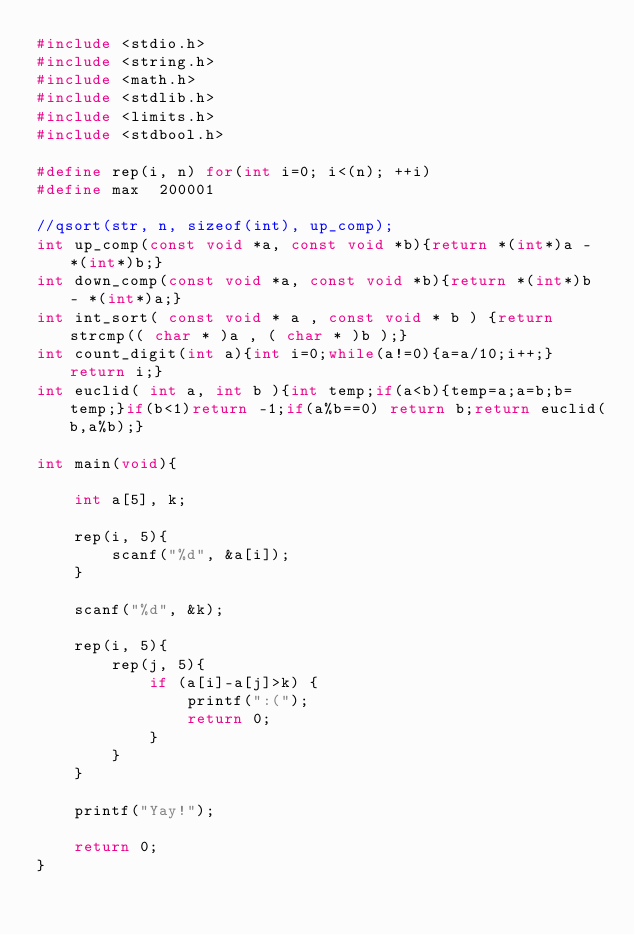<code> <loc_0><loc_0><loc_500><loc_500><_C_>#include <stdio.h>
#include <string.h>
#include <math.h>
#include <stdlib.h>
#include <limits.h>
#include <stdbool.h>

#define rep(i, n) for(int i=0; i<(n); ++i)
#define max  200001

//qsort(str, n, sizeof(int), up_comp);
int up_comp(const void *a, const void *b){return *(int*)a - *(int*)b;}
int down_comp(const void *a, const void *b){return *(int*)b - *(int*)a;}
int int_sort( const void * a , const void * b ) {return strcmp(( char * )a , ( char * )b );}
int count_digit(int a){int i=0;while(a!=0){a=a/10;i++;}return i;}
int euclid( int a, int b ){int temp;if(a<b){temp=a;a=b;b=temp;}if(b<1)return -1;if(a%b==0) return b;return euclid(b,a%b);}

int main(void){
 
    int a[5], k;
    
    rep(i, 5){
        scanf("%d", &a[i]);
    }
    
    scanf("%d", &k);

    rep(i, 5){
        rep(j, 5){
            if (a[i]-a[j]>k) {
                printf(":(");
                return 0;
            }
        }
    }
    
    printf("Yay!");
    
    return 0;
}

</code> 